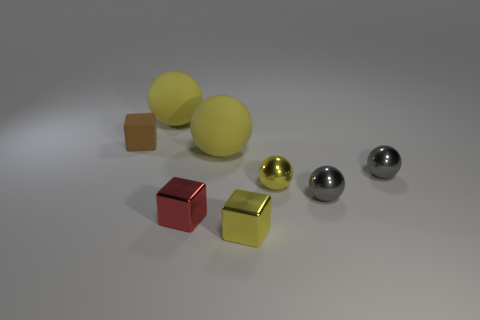Is the yellow object behind the small brown object made of the same material as the big yellow object that is in front of the brown block?
Your answer should be very brief. Yes. What shape is the small object that is both in front of the tiny yellow metallic ball and right of the small yellow cube?
Your answer should be compact. Sphere. What is the tiny gray object that is behind the small yellow thing behind the small red shiny cube made of?
Offer a very short reply. Metal. Is the number of brown objects greater than the number of spheres?
Ensure brevity in your answer.  No. There is a red thing that is the same size as the brown rubber thing; what material is it?
Keep it short and to the point. Metal. Does the red cube have the same material as the tiny yellow cube?
Ensure brevity in your answer.  Yes. How many small red things are made of the same material as the tiny yellow block?
Your response must be concise. 1. How many objects are big matte objects to the left of the tiny red block or small cubes that are on the right side of the red thing?
Offer a terse response. 2. Is the number of tiny brown matte things that are in front of the brown matte cube greater than the number of red things that are in front of the yellow metal ball?
Ensure brevity in your answer.  No. There is a small metallic ball that is in front of the tiny yellow ball; what color is it?
Provide a short and direct response. Gray. 